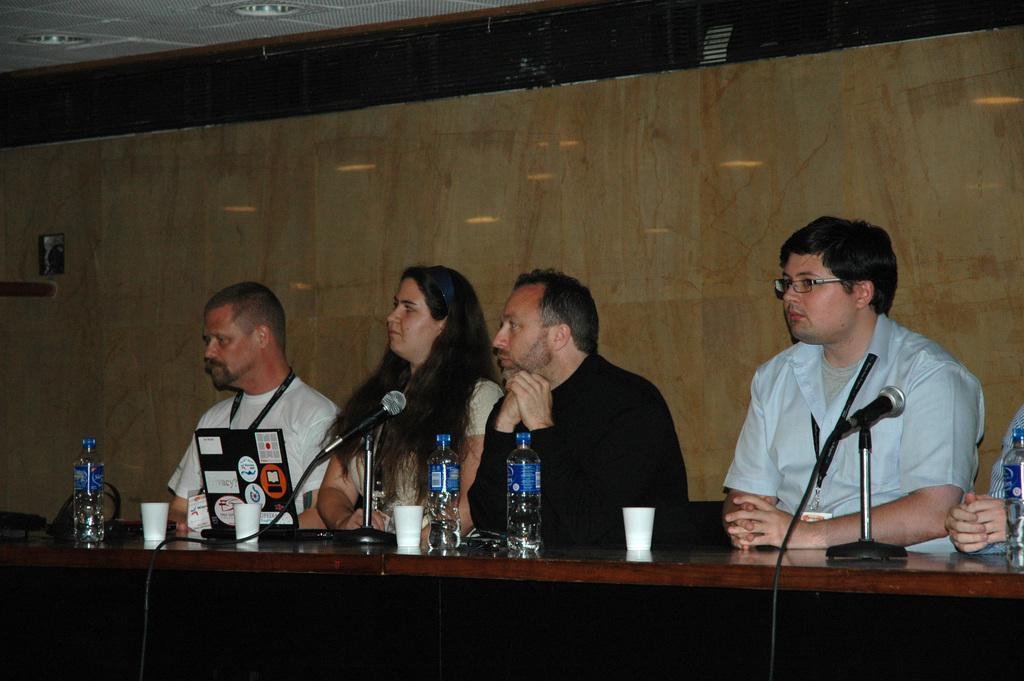Could you give a brief overview of what you see in this image? This image is taken indoors. At the bottom of the image there is a table with many things on it. In the middle of the image a woman and four men are sitting on the chairs. In the background there is a wall. At the top of the image there is a ceiling. 